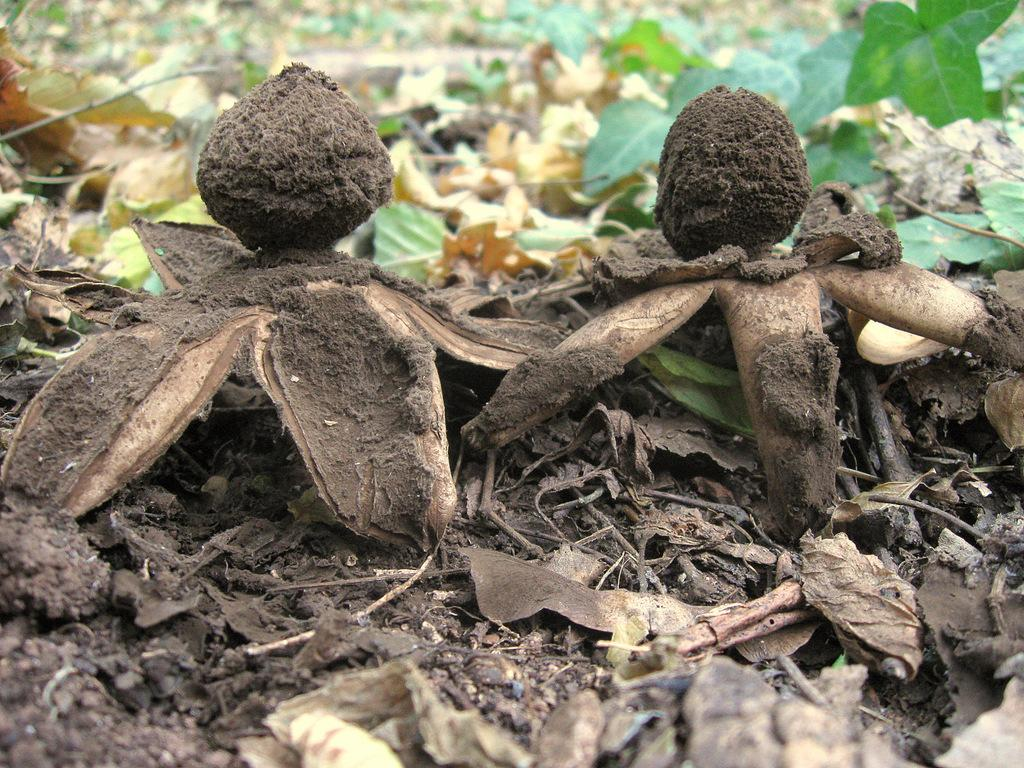What type of natural objects can be seen in the image? There are earth stars and leaves in the image. Can you describe the earth stars in the image? The earth stars are visible in the image. What other type of plant material is present in the image? There are leaves in the image. What type of voice can be heard coming from the earth stars in the image? There is no voice present in the image, as earth stars are inanimate objects and do not produce sound. Is there a collar visible on any of the earth stars in the image? There is no collar present in the image, as earth stars are not living beings that would wear collars. 